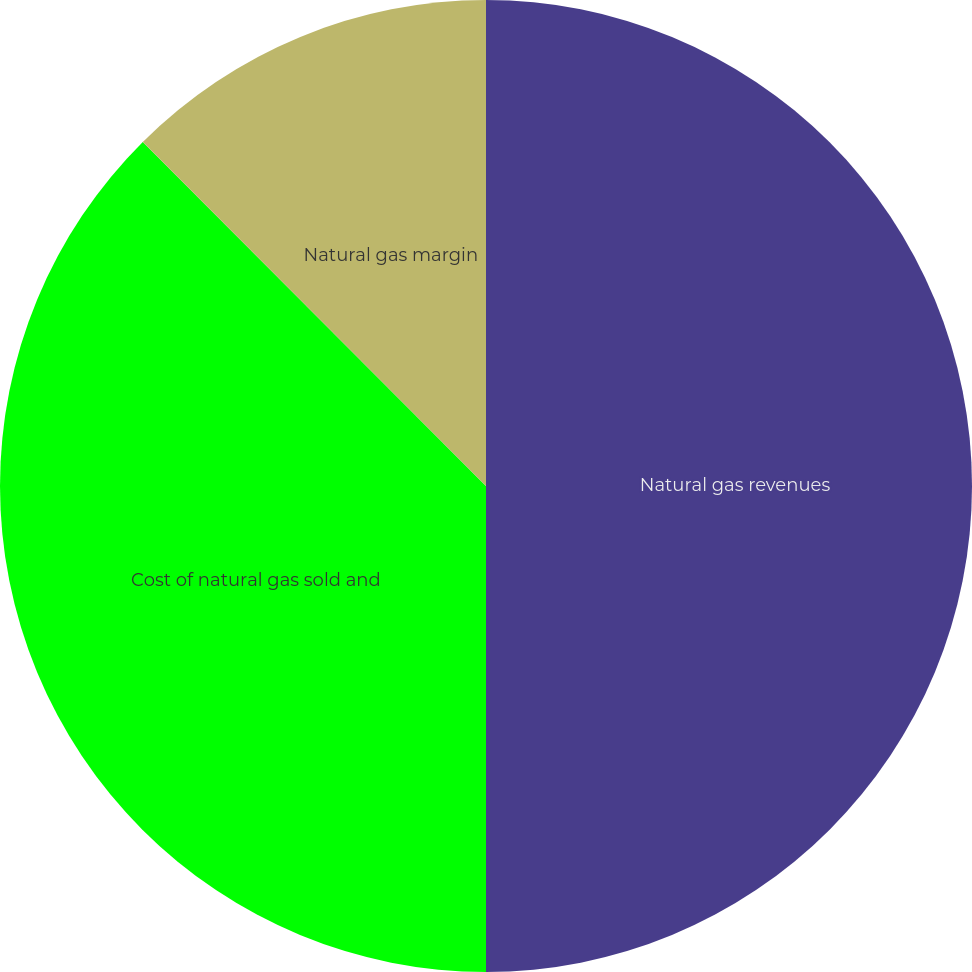Convert chart. <chart><loc_0><loc_0><loc_500><loc_500><pie_chart><fcel>Natural gas revenues<fcel>Cost of natural gas sold and<fcel>Natural gas margin<nl><fcel>50.0%<fcel>37.52%<fcel>12.48%<nl></chart> 